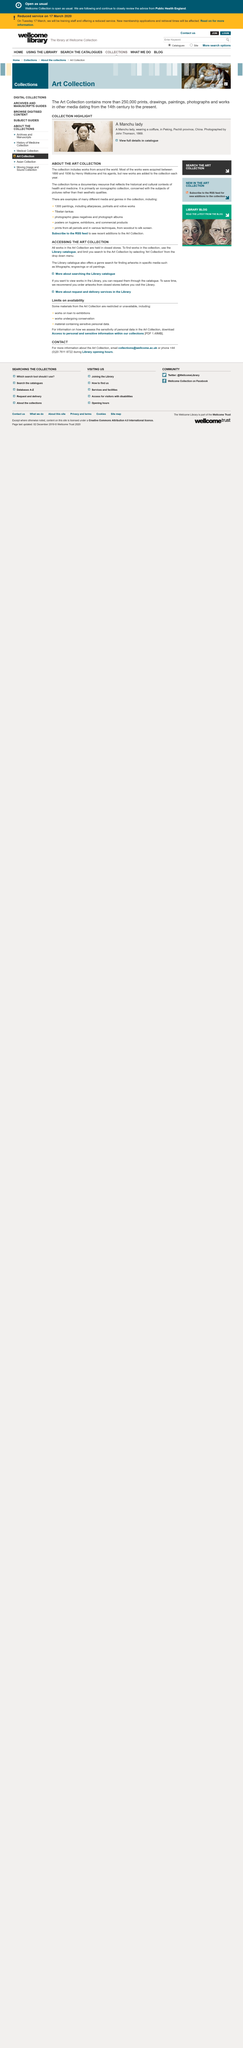Highlight a few significant elements in this photo. To locate works in the Art Collection, it is necessary to use the Library catalogue and specify the Art Collection in the search. This documentary provides a valuable resource that reflects the historical and cultural contexts of health and medicine. Yes, the Library catalogue allows for a genre search for finding artworks in various media, including lithographs, engravings, and oil paintings, among others. The artworks in the Art Collection are stored in secure, closed storage facilities. The works were acquired between 1890 and 1936, with the majority of them being acquired during that time period. 